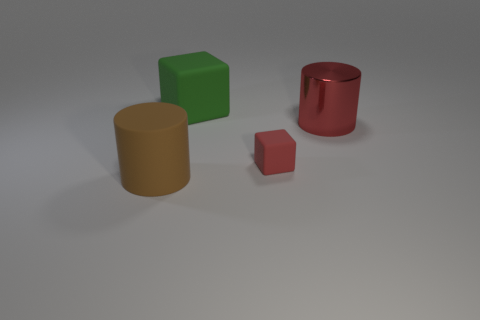Are there any other things that are the same size as the red block?
Your answer should be very brief. No. Are there more matte objects in front of the red matte object than large green rubber things that are on the right side of the large red shiny object?
Ensure brevity in your answer.  Yes. There is a brown cylinder that is made of the same material as the small object; what size is it?
Keep it short and to the point. Large. What number of red metal cylinders are to the left of the large rubber object that is on the right side of the big brown matte object?
Your answer should be compact. 0. Are there any other metallic objects of the same shape as the large green thing?
Make the answer very short. No. There is a large object that is to the left of the big matte object that is behind the big brown matte object; what color is it?
Your response must be concise. Brown. Is the number of tiny red rubber objects greater than the number of tiny red shiny things?
Provide a succinct answer. Yes. What number of other yellow cylinders are the same size as the metallic cylinder?
Offer a very short reply. 0. Do the big red thing and the big green thing that is behind the tiny object have the same material?
Make the answer very short. No. Are there fewer large red matte balls than small rubber objects?
Provide a short and direct response. Yes. 